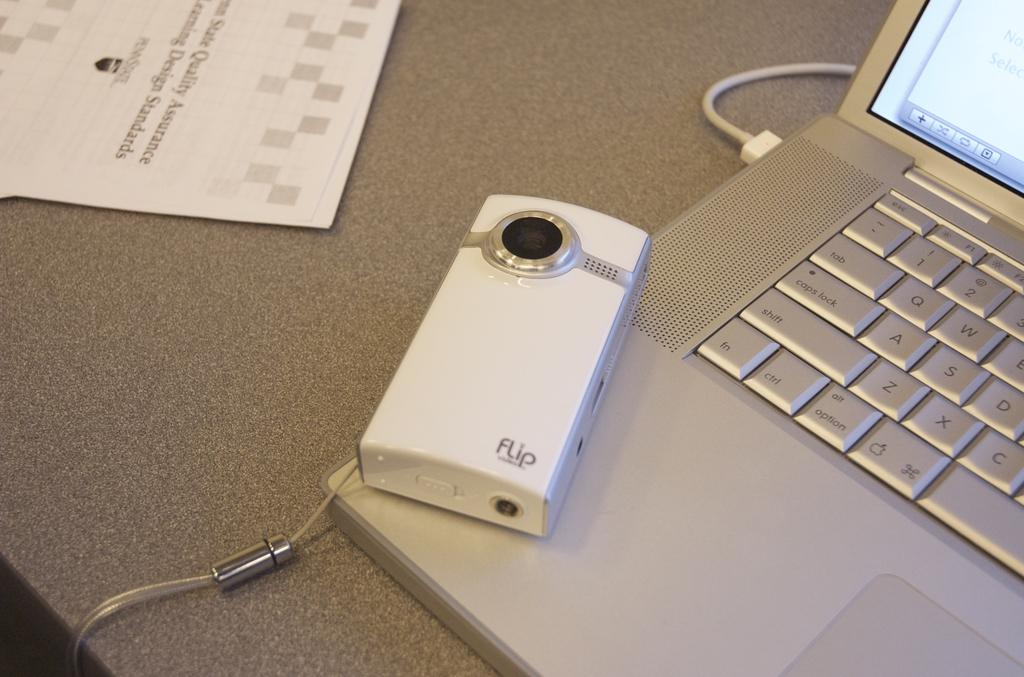Provide a one-sentence caption for the provided image. A white Flip branded camera sitting on the keyboard of a silver laptop computer. 